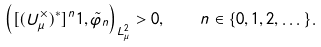<formula> <loc_0><loc_0><loc_500><loc_500>\left ( [ ( U _ { \mu } ^ { \times } ) ^ { \ast } ] ^ { n } { 1 } , \tilde { \varphi } _ { n } \right ) _ { L _ { \mu } ^ { 2 } } > 0 , \quad n \in \{ 0 , 1 , 2 , \dots \} .</formula> 